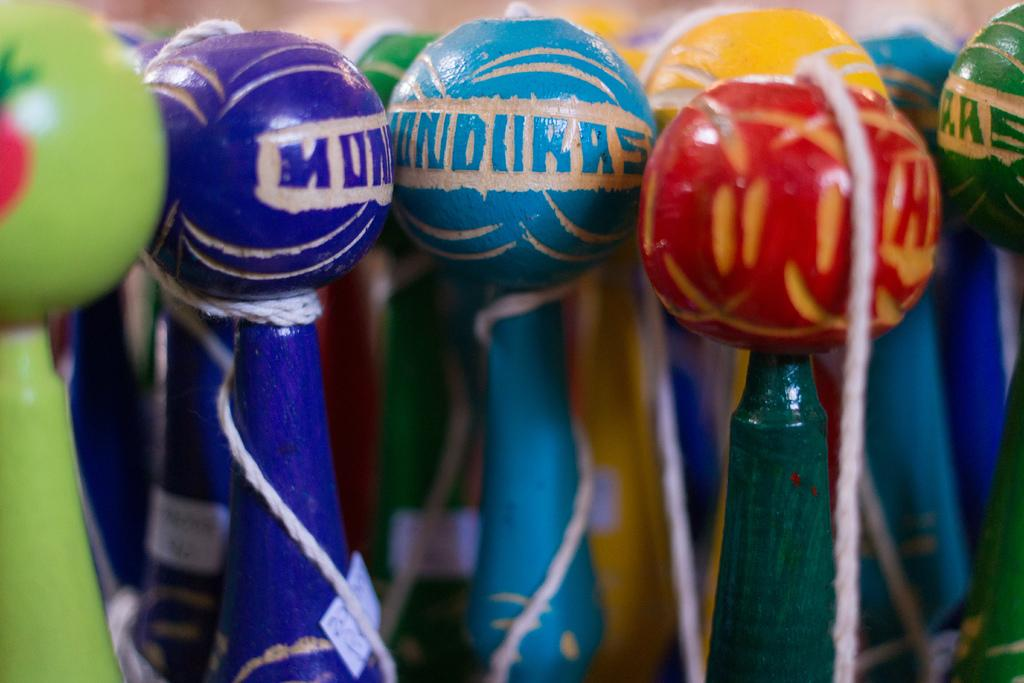What objects can be seen in the image? There are bottles in the image. What is on top of the bottles? There are balls on the bottles. What does the mom say about the sense of humor of the parent in the image? There is no mom or parent present in the image, so it is not possible to answer that question. 